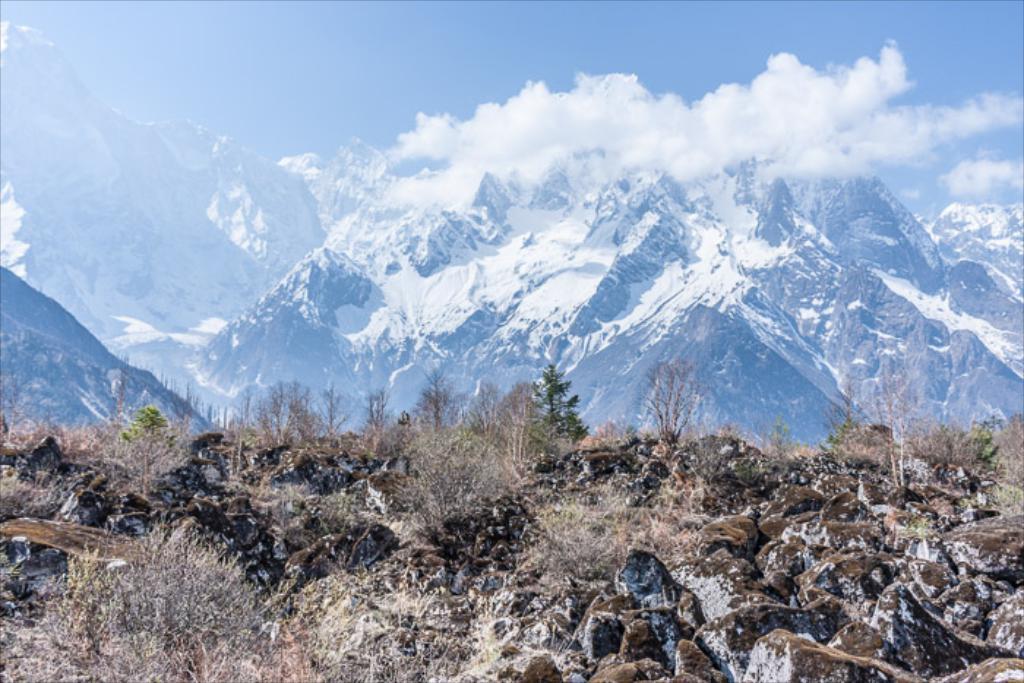In one or two sentences, can you explain what this image depicts? In this image there are rocks and trees in the foreground. There are mountains in the background. And there is sky at the top. 